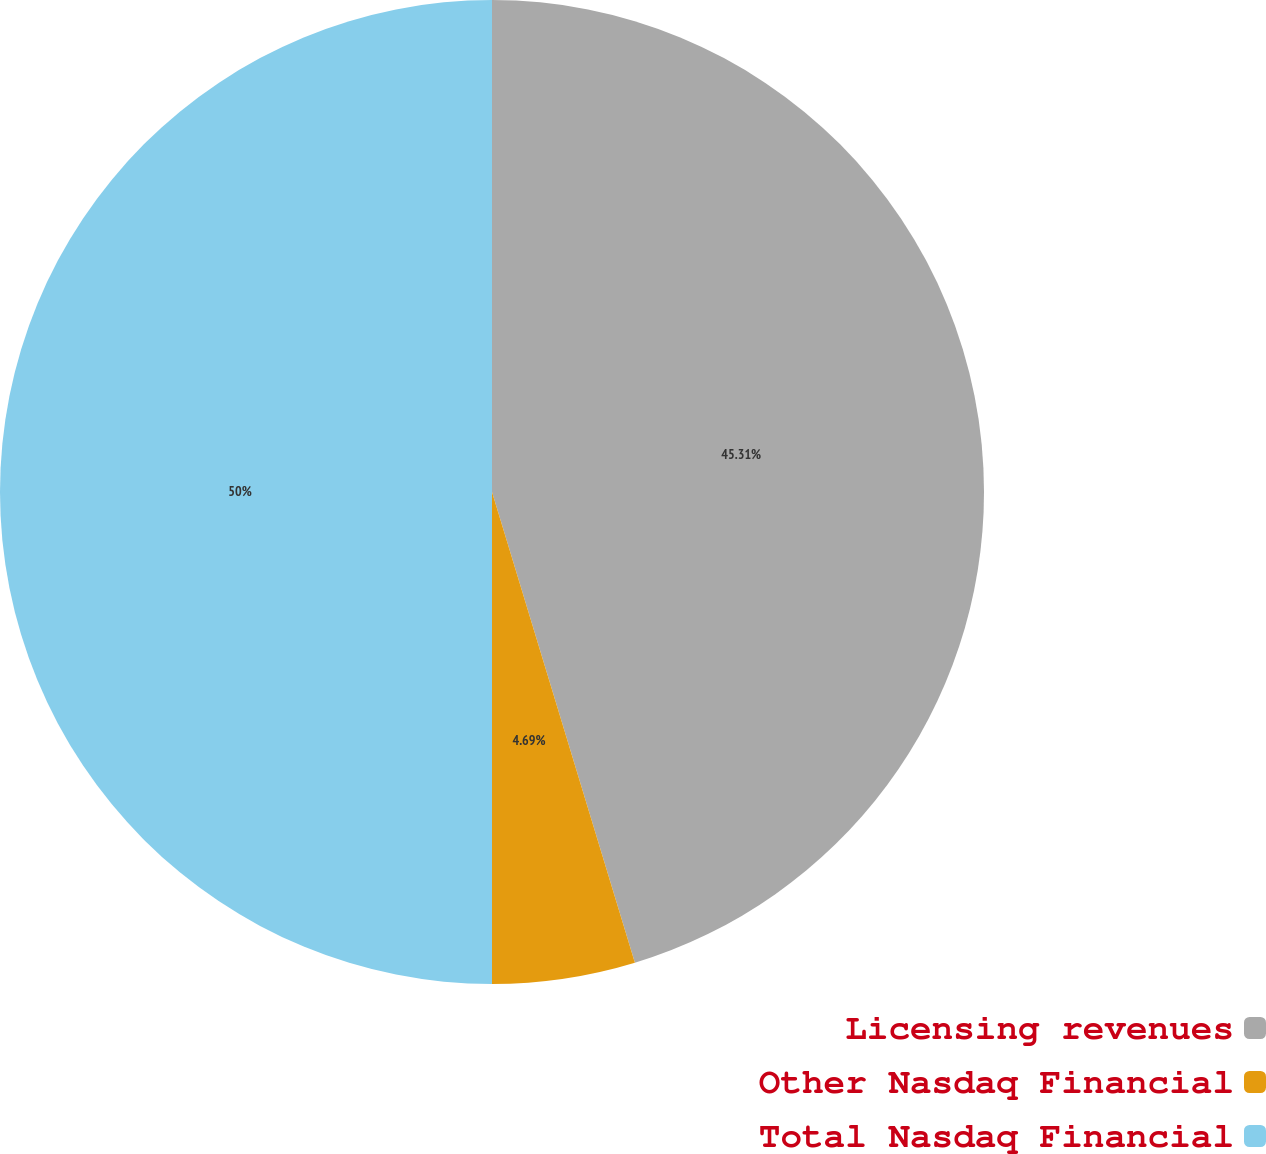Convert chart. <chart><loc_0><loc_0><loc_500><loc_500><pie_chart><fcel>Licensing revenues<fcel>Other Nasdaq Financial<fcel>Total Nasdaq Financial<nl><fcel>45.31%<fcel>4.69%<fcel>50.0%<nl></chart> 